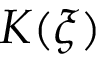<formula> <loc_0><loc_0><loc_500><loc_500>K ( \xi )</formula> 